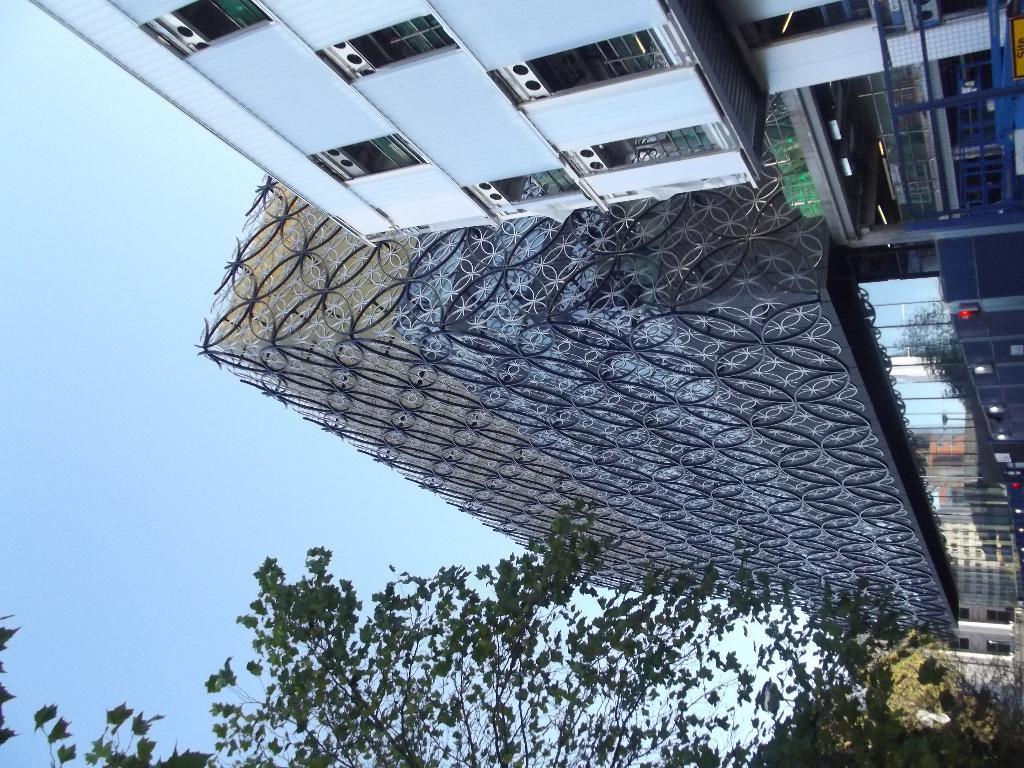What type of structures can be seen in the image? There are buildings in the image. Can you describe the design of the buildings? The architecture of the buildings is visible in the image. What other natural elements are present in the image? There are trees in the image. What is the color of the sky in the image? The sky is blue in the image. How many women are present in the image, and what type of law do they practice? There are no women present in the image, and therefore it is not possible to determine the type of law they practice. 